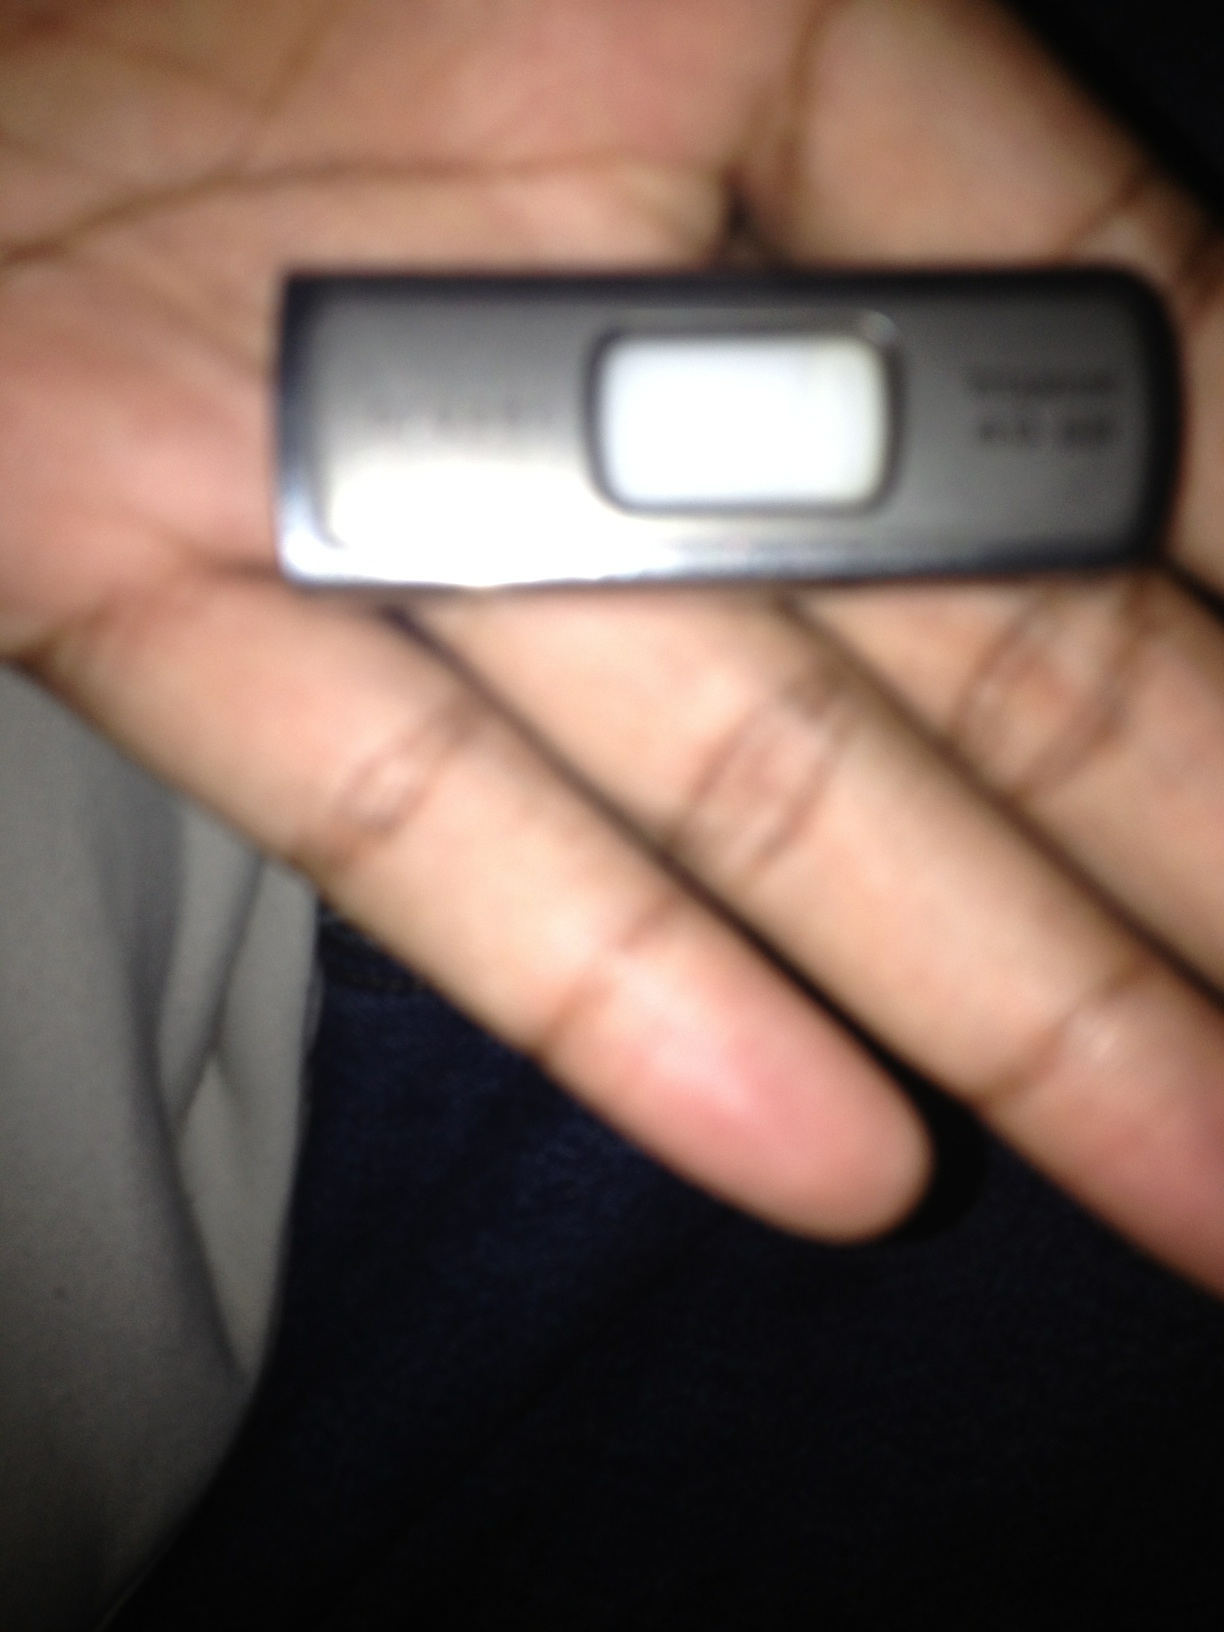How much data can this flash drive hold? The storage capacity of a flash drive can vary widely, ranging from a few megabytes (MB) to several terabytes (TB). Common sizes include 8GB, 16GB, 32GB, 64GB, 128GB, 256GB, and 512GB. The specific capacity of the flash drive in the image would depend on its model and make, which is not immediately clear from the photo. 